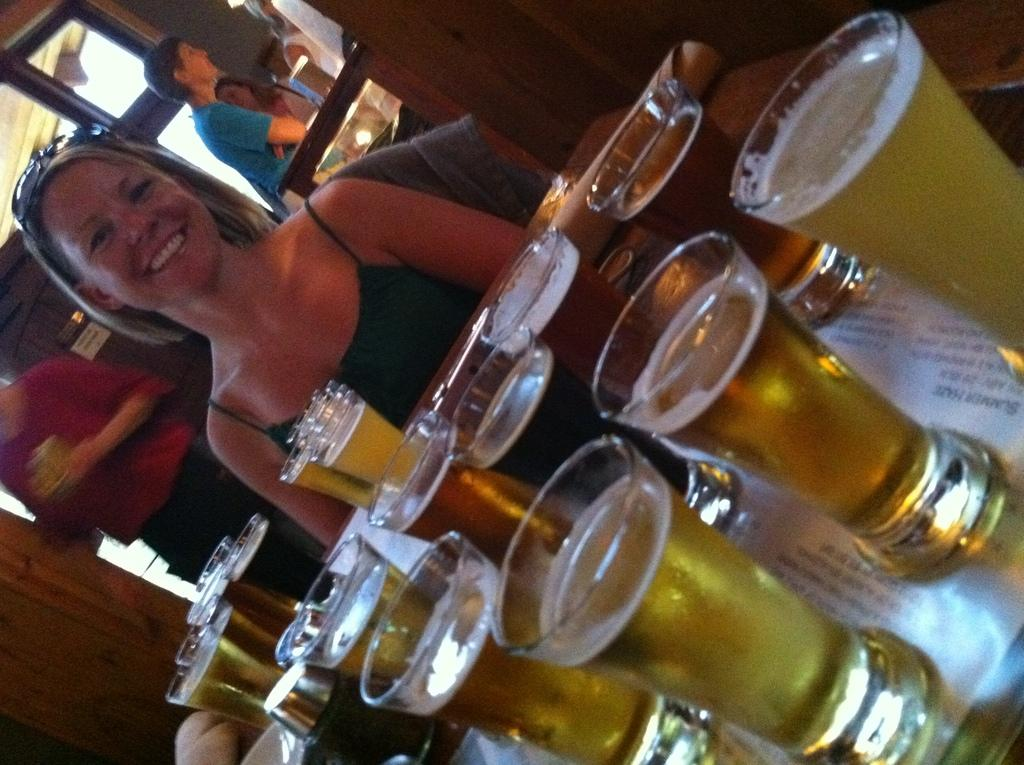What can be seen on the table in the image? There are glasses filled with a drink on the table. What is the lady in the image doing? The lady is sitting and smiling in the image. Can you describe the people in the background of the image? There are people standing in the background of the image. What type of carriage is visible in the image? There is no carriage present in the image. What color is the lady's underwear in the image? The image does not show the lady's underwear, so it cannot be determined. 